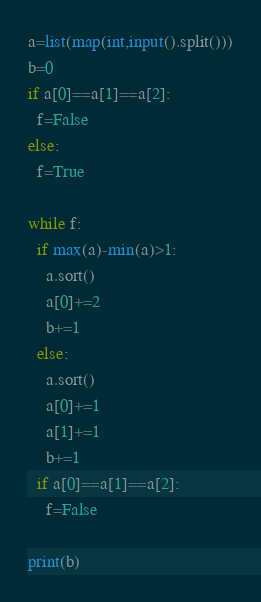<code> <loc_0><loc_0><loc_500><loc_500><_Python_>a=list(map(int,input().split()))
b=0
if a[0]==a[1]==a[2]:
  f=False
else:
  f=True
  
while f:
  if max(a)-min(a)>1:
    a.sort()
    a[0]+=2
    b+=1
  else:
    a.sort()
    a[0]+=1
    a[1]+=1
    b+=1
  if a[0]==a[1]==a[2]:
    f=False

print(b)</code> 